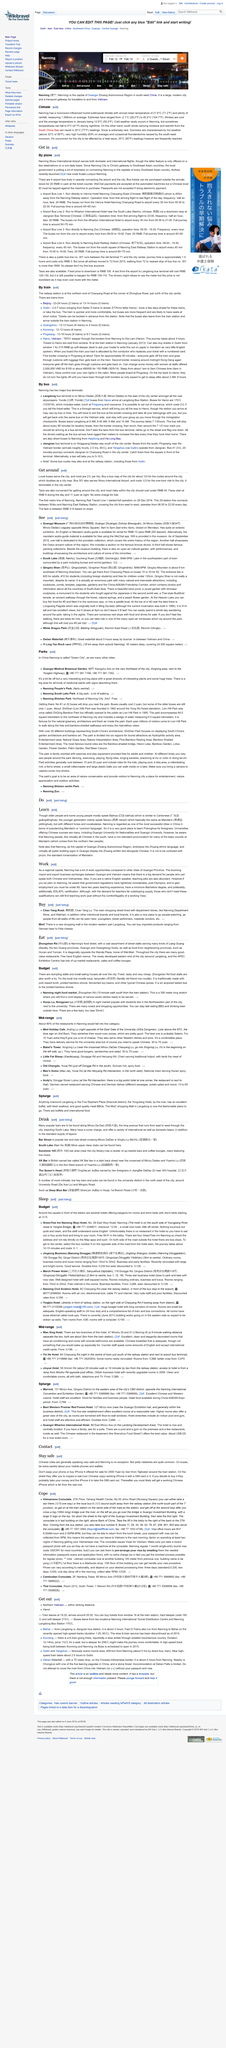Specify some key components in this picture. The first metro line in Nanning began fully operating on December 28, 2016. There are 25 stations on the Nanning Rail Transit Line 1. The Nanning Rail Transit Line 1 operates from 06:30 to 22:00 every day, with its operating hours remaining consistent throughout the week. 